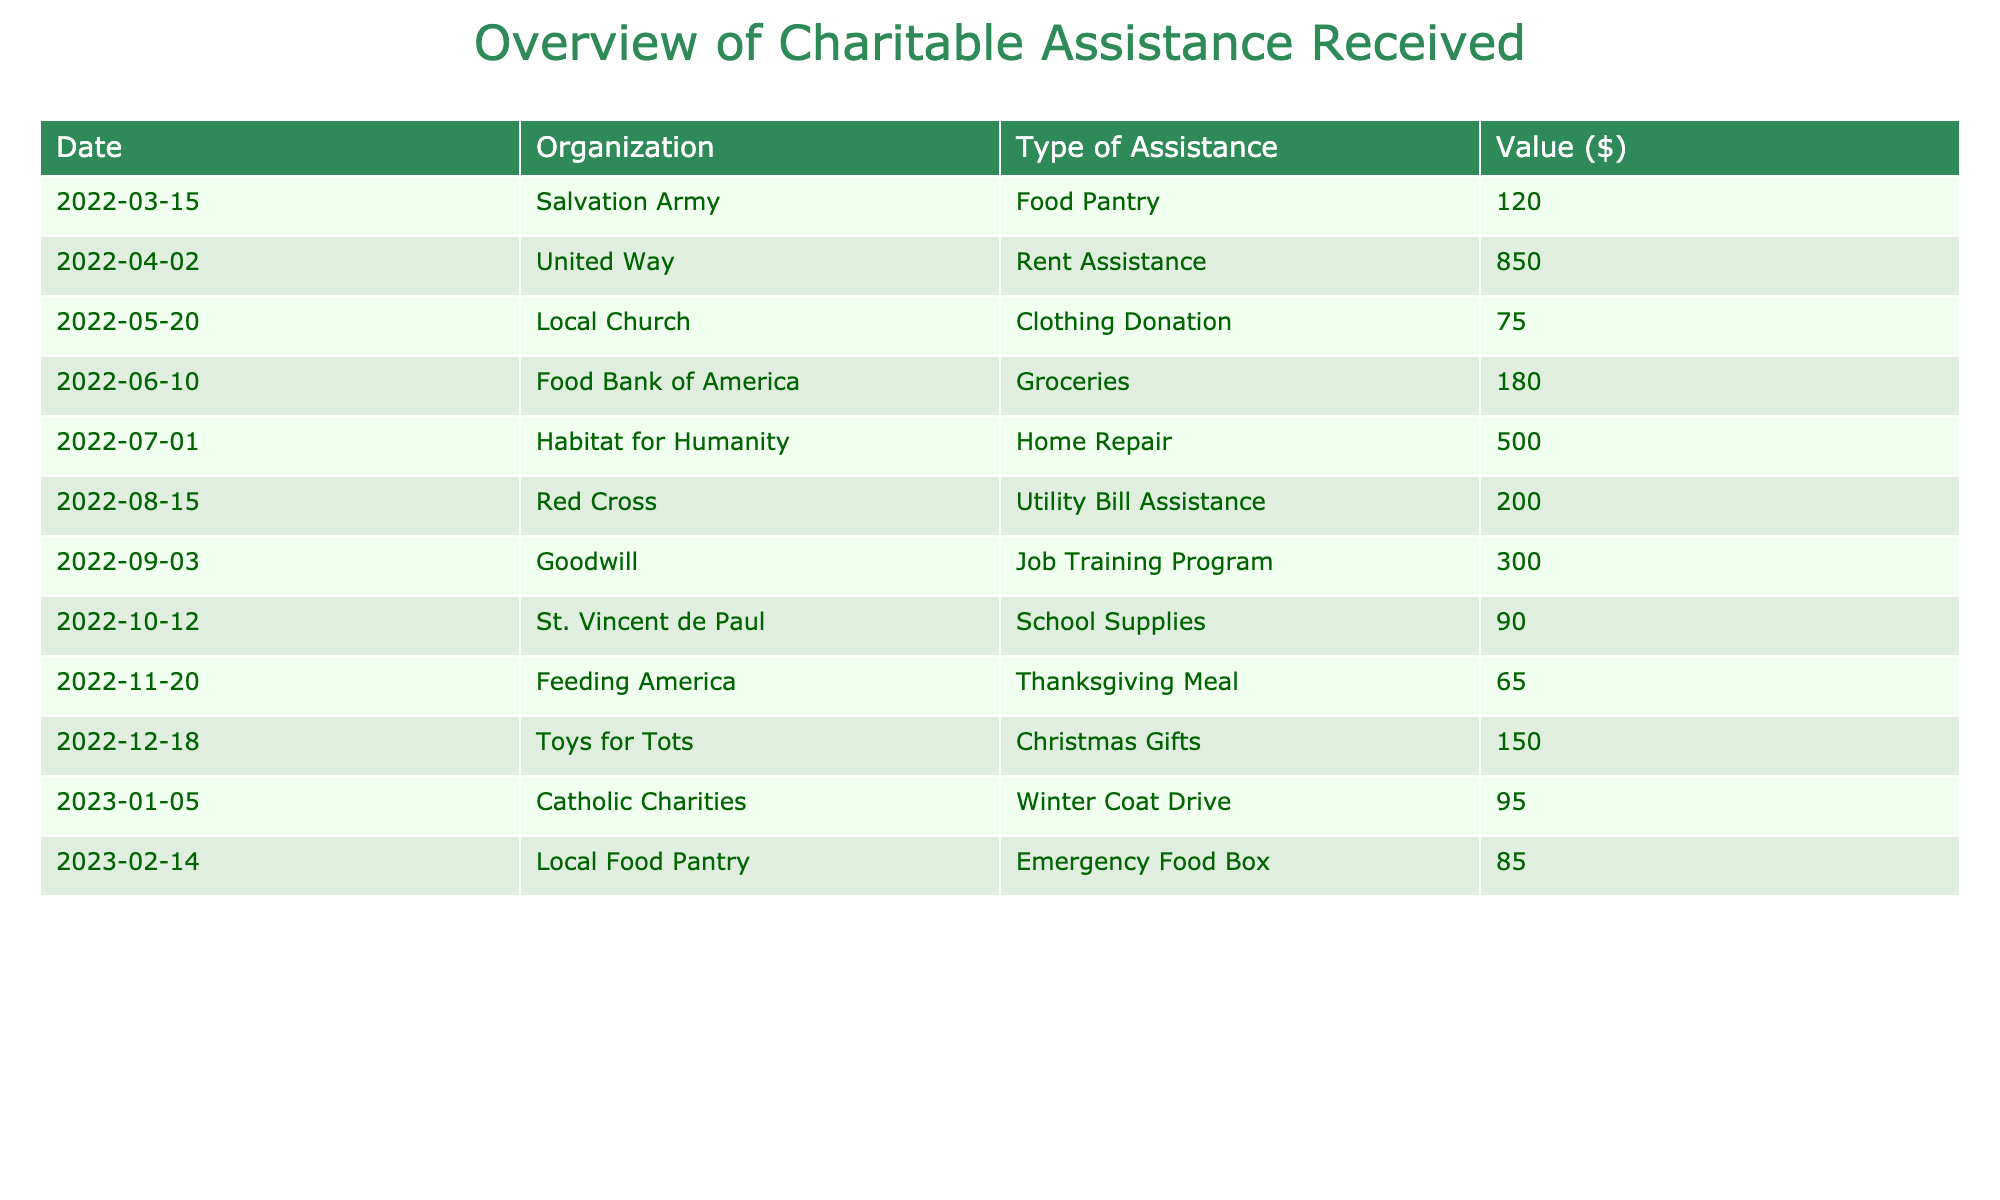What organization provided the highest value of assistance? To find the highest value of assistance, I look at the "Value ($)" column in the table. The highest value is 850, which corresponds to the organization "United Way."
Answer: United Way How much total assistance did I receive from food-related organizations? I will sum the values of the assistance types that are related to food: Food Pantry (120) + Groceries (180) + Emergency Food Box (85) + Thanksgiving Meal (65) = 450.
Answer: 450 Did I receive clothing assistance from any organization? I check the "Type of Assistance" column for any clothing-related entries. There is a "Clothing Donation" entry from "Local Church," so yes, I did receive clothing assistance.
Answer: Yes What is the average value of all assistance types received? First, I calculate the total value of all assistance: (120 + 850 + 75 + 180 + 500 + 200 + 300 + 90 + 65 + 150 + 95 + 85) = 2690. Then, I divide this total by the number of entries, which is 12. Therefore, the average value is 2690 / 12 = 224.17.
Answer: 224.17 Which month had the least amount of assistance received? I will look at the values month-by-month to identify the least amount. The smallest value is 65 from "Feeding America" in November 2022, so November had the least assistance received.
Answer: November How many different organizations provided assistance? I will count the number of unique organizations listed in the table. There are 12 different organizations: Salvation Army, United Way, Local Church, Food Bank of America, Habitat for Humanity, Red Cross, Goodwill, St. Vincent de Paul, Feeding America, Toys for Tots, Catholic Charities, and Local Food Pantry.
Answer: 12 What percentage of the total assistance value did the "Home Repair" assistance represent? First, I find the total value, which is 2690, and the value for "Home Repair," which is 500. Then, I calculate the percentage: (500 / 2690) * 100 ≈ 18.59%.
Answer: 18.59% Was there any assistance received specifically for utilities? I check the "Type of Assistance" column for any utility-related entries. There is a "Utility Bill Assistance" entry from "Red Cross," which confirms I received assistance for utilities.
Answer: Yes If I combine all the rental and housing related assistance, what would be the total value? I locate the "Rent Assistance" (850) and "Home Repair" (500) entries. Adding these gives 850 + 500 = 1350.
Answer: 1350 What type of assistance is the most frequently provided by the organizations? By examining the "Type of Assistance" entries, I see "Utility Bill Assistance," "Job Training Program," "Winter Coat Drive," and "Clothing Donation" are unique. Others like food-related assistance are also included, but categories like Rent Assistance and "Home Repair" appear once. No type repeats except food-related ones. The most frequently provided assistance types are food-related.
Answer: Food-related assistance 